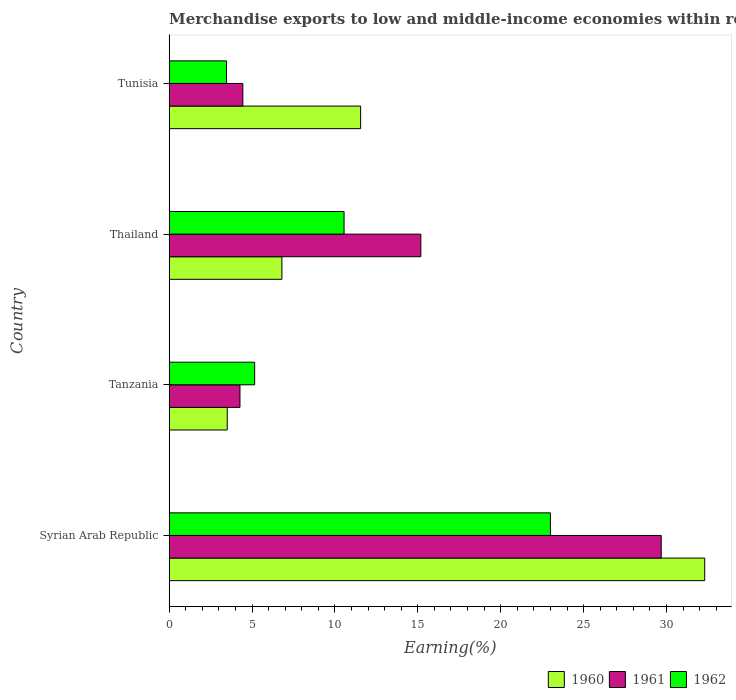How many different coloured bars are there?
Your response must be concise. 3. How many groups of bars are there?
Your answer should be very brief. 4. What is the label of the 4th group of bars from the top?
Your answer should be compact. Syrian Arab Republic. In how many cases, is the number of bars for a given country not equal to the number of legend labels?
Your response must be concise. 0. What is the percentage of amount earned from merchandise exports in 1960 in Thailand?
Give a very brief answer. 6.8. Across all countries, what is the maximum percentage of amount earned from merchandise exports in 1960?
Make the answer very short. 32.31. Across all countries, what is the minimum percentage of amount earned from merchandise exports in 1961?
Provide a succinct answer. 4.27. In which country was the percentage of amount earned from merchandise exports in 1960 maximum?
Provide a succinct answer. Syrian Arab Republic. In which country was the percentage of amount earned from merchandise exports in 1960 minimum?
Your response must be concise. Tanzania. What is the total percentage of amount earned from merchandise exports in 1960 in the graph?
Provide a short and direct response. 54.16. What is the difference between the percentage of amount earned from merchandise exports in 1961 in Syrian Arab Republic and that in Tanzania?
Provide a short and direct response. 25.41. What is the difference between the percentage of amount earned from merchandise exports in 1961 in Thailand and the percentage of amount earned from merchandise exports in 1960 in Tunisia?
Keep it short and to the point. 3.63. What is the average percentage of amount earned from merchandise exports in 1962 per country?
Provide a succinct answer. 10.54. What is the difference between the percentage of amount earned from merchandise exports in 1960 and percentage of amount earned from merchandise exports in 1962 in Syrian Arab Republic?
Make the answer very short. 9.31. In how many countries, is the percentage of amount earned from merchandise exports in 1960 greater than 4 %?
Your answer should be compact. 3. What is the ratio of the percentage of amount earned from merchandise exports in 1960 in Syrian Arab Republic to that in Tunisia?
Make the answer very short. 2.8. Is the percentage of amount earned from merchandise exports in 1960 in Tanzania less than that in Tunisia?
Ensure brevity in your answer.  Yes. What is the difference between the highest and the second highest percentage of amount earned from merchandise exports in 1961?
Provide a succinct answer. 14.5. What is the difference between the highest and the lowest percentage of amount earned from merchandise exports in 1962?
Provide a short and direct response. 19.54. In how many countries, is the percentage of amount earned from merchandise exports in 1962 greater than the average percentage of amount earned from merchandise exports in 1962 taken over all countries?
Your response must be concise. 2. Is the sum of the percentage of amount earned from merchandise exports in 1960 in Syrian Arab Republic and Tanzania greater than the maximum percentage of amount earned from merchandise exports in 1961 across all countries?
Ensure brevity in your answer.  Yes. Is it the case that in every country, the sum of the percentage of amount earned from merchandise exports in 1960 and percentage of amount earned from merchandise exports in 1962 is greater than the percentage of amount earned from merchandise exports in 1961?
Offer a very short reply. Yes. How many bars are there?
Your response must be concise. 12. Are all the bars in the graph horizontal?
Offer a terse response. Yes. Does the graph contain grids?
Provide a succinct answer. No. How many legend labels are there?
Offer a very short reply. 3. How are the legend labels stacked?
Provide a short and direct response. Horizontal. What is the title of the graph?
Provide a succinct answer. Merchandise exports to low and middle-income economies within region. What is the label or title of the X-axis?
Your answer should be compact. Earning(%). What is the label or title of the Y-axis?
Your response must be concise. Country. What is the Earning(%) in 1960 in Syrian Arab Republic?
Ensure brevity in your answer.  32.31. What is the Earning(%) of 1961 in Syrian Arab Republic?
Your answer should be compact. 29.68. What is the Earning(%) in 1962 in Syrian Arab Republic?
Give a very brief answer. 23. What is the Earning(%) in 1960 in Tanzania?
Your response must be concise. 3.5. What is the Earning(%) of 1961 in Tanzania?
Your response must be concise. 4.27. What is the Earning(%) in 1962 in Tanzania?
Provide a succinct answer. 5.16. What is the Earning(%) in 1960 in Thailand?
Offer a terse response. 6.8. What is the Earning(%) in 1961 in Thailand?
Make the answer very short. 15.18. What is the Earning(%) of 1962 in Thailand?
Provide a short and direct response. 10.55. What is the Earning(%) in 1960 in Tunisia?
Provide a short and direct response. 11.55. What is the Earning(%) in 1961 in Tunisia?
Your answer should be compact. 4.44. What is the Earning(%) of 1962 in Tunisia?
Provide a succinct answer. 3.46. Across all countries, what is the maximum Earning(%) of 1960?
Provide a succinct answer. 32.31. Across all countries, what is the maximum Earning(%) of 1961?
Your answer should be very brief. 29.68. Across all countries, what is the maximum Earning(%) of 1962?
Provide a short and direct response. 23. Across all countries, what is the minimum Earning(%) of 1960?
Give a very brief answer. 3.5. Across all countries, what is the minimum Earning(%) of 1961?
Provide a short and direct response. 4.27. Across all countries, what is the minimum Earning(%) in 1962?
Make the answer very short. 3.46. What is the total Earning(%) in 1960 in the graph?
Keep it short and to the point. 54.16. What is the total Earning(%) in 1961 in the graph?
Your answer should be compact. 53.58. What is the total Earning(%) in 1962 in the graph?
Your answer should be very brief. 42.16. What is the difference between the Earning(%) in 1960 in Syrian Arab Republic and that in Tanzania?
Your response must be concise. 28.81. What is the difference between the Earning(%) in 1961 in Syrian Arab Republic and that in Tanzania?
Your answer should be compact. 25.41. What is the difference between the Earning(%) in 1962 in Syrian Arab Republic and that in Tanzania?
Your answer should be very brief. 17.84. What is the difference between the Earning(%) of 1960 in Syrian Arab Republic and that in Thailand?
Keep it short and to the point. 25.51. What is the difference between the Earning(%) in 1961 in Syrian Arab Republic and that in Thailand?
Make the answer very short. 14.5. What is the difference between the Earning(%) in 1962 in Syrian Arab Republic and that in Thailand?
Ensure brevity in your answer.  12.45. What is the difference between the Earning(%) of 1960 in Syrian Arab Republic and that in Tunisia?
Your response must be concise. 20.76. What is the difference between the Earning(%) of 1961 in Syrian Arab Republic and that in Tunisia?
Provide a succinct answer. 25.24. What is the difference between the Earning(%) in 1962 in Syrian Arab Republic and that in Tunisia?
Keep it short and to the point. 19.54. What is the difference between the Earning(%) of 1960 in Tanzania and that in Thailand?
Offer a very short reply. -3.3. What is the difference between the Earning(%) in 1961 in Tanzania and that in Thailand?
Give a very brief answer. -10.91. What is the difference between the Earning(%) of 1962 in Tanzania and that in Thailand?
Offer a very short reply. -5.39. What is the difference between the Earning(%) of 1960 in Tanzania and that in Tunisia?
Your answer should be compact. -8.05. What is the difference between the Earning(%) in 1961 in Tanzania and that in Tunisia?
Keep it short and to the point. -0.17. What is the difference between the Earning(%) of 1962 in Tanzania and that in Tunisia?
Keep it short and to the point. 1.7. What is the difference between the Earning(%) of 1960 in Thailand and that in Tunisia?
Your response must be concise. -4.75. What is the difference between the Earning(%) of 1961 in Thailand and that in Tunisia?
Offer a very short reply. 10.74. What is the difference between the Earning(%) in 1962 in Thailand and that in Tunisia?
Make the answer very short. 7.09. What is the difference between the Earning(%) of 1960 in Syrian Arab Republic and the Earning(%) of 1961 in Tanzania?
Provide a succinct answer. 28.04. What is the difference between the Earning(%) in 1960 in Syrian Arab Republic and the Earning(%) in 1962 in Tanzania?
Provide a succinct answer. 27.15. What is the difference between the Earning(%) of 1961 in Syrian Arab Republic and the Earning(%) of 1962 in Tanzania?
Offer a very short reply. 24.53. What is the difference between the Earning(%) in 1960 in Syrian Arab Republic and the Earning(%) in 1961 in Thailand?
Ensure brevity in your answer.  17.13. What is the difference between the Earning(%) of 1960 in Syrian Arab Republic and the Earning(%) of 1962 in Thailand?
Ensure brevity in your answer.  21.76. What is the difference between the Earning(%) in 1961 in Syrian Arab Republic and the Earning(%) in 1962 in Thailand?
Your response must be concise. 19.13. What is the difference between the Earning(%) in 1960 in Syrian Arab Republic and the Earning(%) in 1961 in Tunisia?
Provide a succinct answer. 27.87. What is the difference between the Earning(%) in 1960 in Syrian Arab Republic and the Earning(%) in 1962 in Tunisia?
Offer a very short reply. 28.85. What is the difference between the Earning(%) of 1961 in Syrian Arab Republic and the Earning(%) of 1962 in Tunisia?
Your answer should be compact. 26.23. What is the difference between the Earning(%) in 1960 in Tanzania and the Earning(%) in 1961 in Thailand?
Ensure brevity in your answer.  -11.68. What is the difference between the Earning(%) in 1960 in Tanzania and the Earning(%) in 1962 in Thailand?
Give a very brief answer. -7.05. What is the difference between the Earning(%) of 1961 in Tanzania and the Earning(%) of 1962 in Thailand?
Keep it short and to the point. -6.28. What is the difference between the Earning(%) in 1960 in Tanzania and the Earning(%) in 1961 in Tunisia?
Provide a succinct answer. -0.94. What is the difference between the Earning(%) in 1960 in Tanzania and the Earning(%) in 1962 in Tunisia?
Offer a terse response. 0.04. What is the difference between the Earning(%) in 1961 in Tanzania and the Earning(%) in 1962 in Tunisia?
Provide a succinct answer. 0.81. What is the difference between the Earning(%) of 1960 in Thailand and the Earning(%) of 1961 in Tunisia?
Offer a very short reply. 2.36. What is the difference between the Earning(%) of 1960 in Thailand and the Earning(%) of 1962 in Tunisia?
Ensure brevity in your answer.  3.34. What is the difference between the Earning(%) in 1961 in Thailand and the Earning(%) in 1962 in Tunisia?
Offer a very short reply. 11.72. What is the average Earning(%) in 1960 per country?
Provide a succinct answer. 13.54. What is the average Earning(%) of 1961 per country?
Ensure brevity in your answer.  13.39. What is the average Earning(%) of 1962 per country?
Make the answer very short. 10.54. What is the difference between the Earning(%) in 1960 and Earning(%) in 1961 in Syrian Arab Republic?
Offer a very short reply. 2.62. What is the difference between the Earning(%) in 1960 and Earning(%) in 1962 in Syrian Arab Republic?
Provide a succinct answer. 9.31. What is the difference between the Earning(%) in 1961 and Earning(%) in 1962 in Syrian Arab Republic?
Offer a very short reply. 6.68. What is the difference between the Earning(%) in 1960 and Earning(%) in 1961 in Tanzania?
Your answer should be compact. -0.77. What is the difference between the Earning(%) of 1960 and Earning(%) of 1962 in Tanzania?
Make the answer very short. -1.65. What is the difference between the Earning(%) of 1961 and Earning(%) of 1962 in Tanzania?
Your answer should be very brief. -0.89. What is the difference between the Earning(%) in 1960 and Earning(%) in 1961 in Thailand?
Keep it short and to the point. -8.38. What is the difference between the Earning(%) in 1960 and Earning(%) in 1962 in Thailand?
Make the answer very short. -3.75. What is the difference between the Earning(%) in 1961 and Earning(%) in 1962 in Thailand?
Provide a short and direct response. 4.63. What is the difference between the Earning(%) in 1960 and Earning(%) in 1961 in Tunisia?
Your answer should be compact. 7.11. What is the difference between the Earning(%) of 1960 and Earning(%) of 1962 in Tunisia?
Ensure brevity in your answer.  8.09. What is the difference between the Earning(%) in 1961 and Earning(%) in 1962 in Tunisia?
Your response must be concise. 0.99. What is the ratio of the Earning(%) of 1960 in Syrian Arab Republic to that in Tanzania?
Ensure brevity in your answer.  9.23. What is the ratio of the Earning(%) in 1961 in Syrian Arab Republic to that in Tanzania?
Offer a terse response. 6.95. What is the ratio of the Earning(%) in 1962 in Syrian Arab Republic to that in Tanzania?
Your answer should be compact. 4.46. What is the ratio of the Earning(%) of 1960 in Syrian Arab Republic to that in Thailand?
Ensure brevity in your answer.  4.75. What is the ratio of the Earning(%) in 1961 in Syrian Arab Republic to that in Thailand?
Ensure brevity in your answer.  1.96. What is the ratio of the Earning(%) in 1962 in Syrian Arab Republic to that in Thailand?
Ensure brevity in your answer.  2.18. What is the ratio of the Earning(%) in 1960 in Syrian Arab Republic to that in Tunisia?
Offer a very short reply. 2.8. What is the ratio of the Earning(%) of 1961 in Syrian Arab Republic to that in Tunisia?
Offer a terse response. 6.68. What is the ratio of the Earning(%) in 1962 in Syrian Arab Republic to that in Tunisia?
Keep it short and to the point. 6.65. What is the ratio of the Earning(%) of 1960 in Tanzania to that in Thailand?
Provide a succinct answer. 0.52. What is the ratio of the Earning(%) of 1961 in Tanzania to that in Thailand?
Keep it short and to the point. 0.28. What is the ratio of the Earning(%) in 1962 in Tanzania to that in Thailand?
Your answer should be very brief. 0.49. What is the ratio of the Earning(%) of 1960 in Tanzania to that in Tunisia?
Provide a succinct answer. 0.3. What is the ratio of the Earning(%) of 1961 in Tanzania to that in Tunisia?
Keep it short and to the point. 0.96. What is the ratio of the Earning(%) in 1962 in Tanzania to that in Tunisia?
Your response must be concise. 1.49. What is the ratio of the Earning(%) in 1960 in Thailand to that in Tunisia?
Offer a very short reply. 0.59. What is the ratio of the Earning(%) of 1961 in Thailand to that in Tunisia?
Give a very brief answer. 3.42. What is the ratio of the Earning(%) in 1962 in Thailand to that in Tunisia?
Provide a short and direct response. 3.05. What is the difference between the highest and the second highest Earning(%) in 1960?
Your answer should be very brief. 20.76. What is the difference between the highest and the second highest Earning(%) in 1961?
Ensure brevity in your answer.  14.5. What is the difference between the highest and the second highest Earning(%) of 1962?
Ensure brevity in your answer.  12.45. What is the difference between the highest and the lowest Earning(%) in 1960?
Offer a terse response. 28.81. What is the difference between the highest and the lowest Earning(%) of 1961?
Ensure brevity in your answer.  25.41. What is the difference between the highest and the lowest Earning(%) in 1962?
Keep it short and to the point. 19.54. 